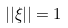Convert formula to latex. <formula><loc_0><loc_0><loc_500><loc_500>| | \xi | | = 1</formula> 